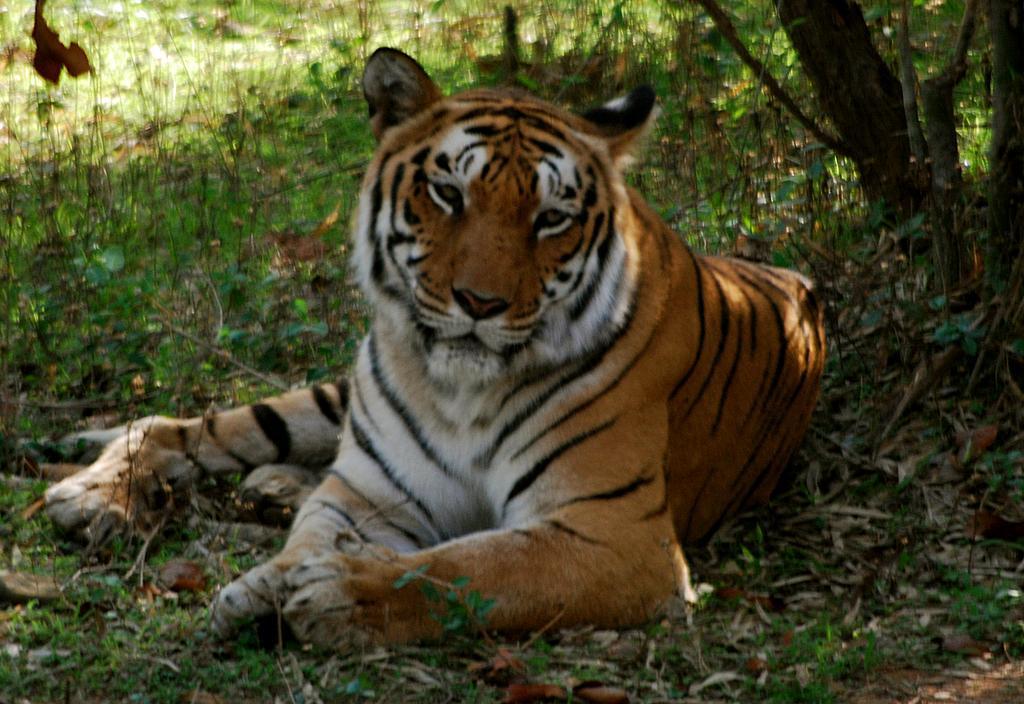Please provide a concise description of this image. In the center of the image we can see a tiger. We can also see the grass, dried leaves and also the trees on the right. 